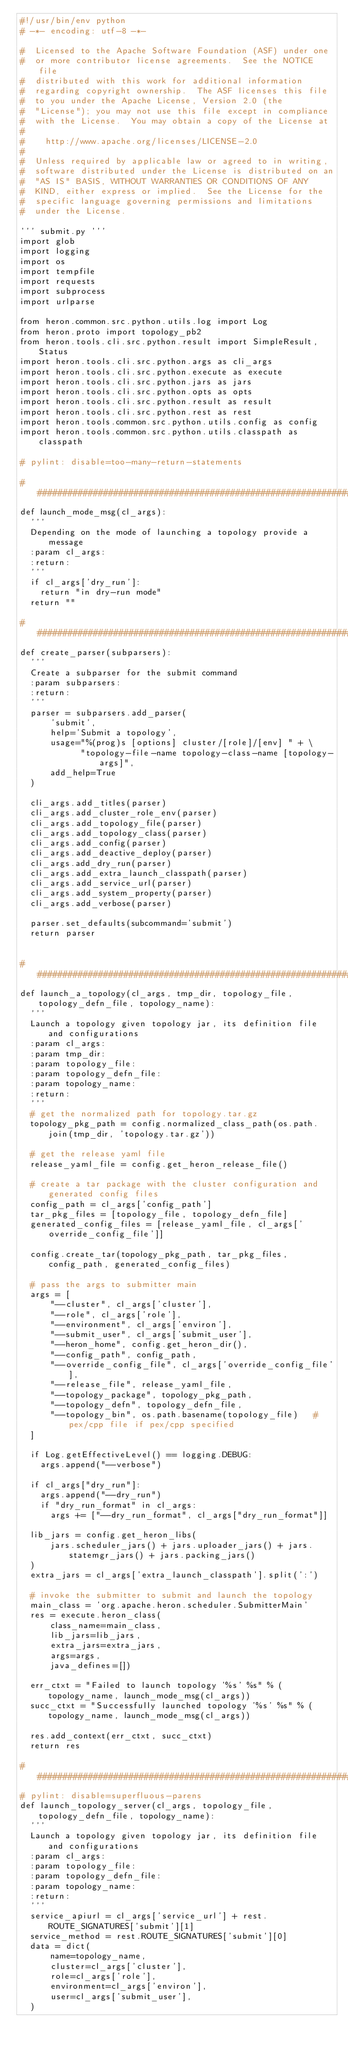<code> <loc_0><loc_0><loc_500><loc_500><_Python_>#!/usr/bin/env python
# -*- encoding: utf-8 -*-

#  Licensed to the Apache Software Foundation (ASF) under one
#  or more contributor license agreements.  See the NOTICE file
#  distributed with this work for additional information
#  regarding copyright ownership.  The ASF licenses this file
#  to you under the Apache License, Version 2.0 (the
#  "License"); you may not use this file except in compliance
#  with the License.  You may obtain a copy of the License at
#
#    http://www.apache.org/licenses/LICENSE-2.0
#
#  Unless required by applicable law or agreed to in writing,
#  software distributed under the License is distributed on an
#  "AS IS" BASIS, WITHOUT WARRANTIES OR CONDITIONS OF ANY
#  KIND, either express or implied.  See the License for the
#  specific language governing permissions and limitations
#  under the License.

''' submit.py '''
import glob
import logging
import os
import tempfile
import requests
import subprocess
import urlparse

from heron.common.src.python.utils.log import Log
from heron.proto import topology_pb2
from heron.tools.cli.src.python.result import SimpleResult, Status
import heron.tools.cli.src.python.args as cli_args
import heron.tools.cli.src.python.execute as execute
import heron.tools.cli.src.python.jars as jars
import heron.tools.cli.src.python.opts as opts
import heron.tools.cli.src.python.result as result
import heron.tools.cli.src.python.rest as rest
import heron.tools.common.src.python.utils.config as config
import heron.tools.common.src.python.utils.classpath as classpath

# pylint: disable=too-many-return-statements

################################################################################
def launch_mode_msg(cl_args):
  '''
  Depending on the mode of launching a topology provide a message
  :param cl_args:
  :return:
  '''
  if cl_args['dry_run']:
    return "in dry-run mode"
  return ""

################################################################################
def create_parser(subparsers):
  '''
  Create a subparser for the submit command
  :param subparsers:
  :return:
  '''
  parser = subparsers.add_parser(
      'submit',
      help='Submit a topology',
      usage="%(prog)s [options] cluster/[role]/[env] " + \
            "topology-file-name topology-class-name [topology-args]",
      add_help=True
  )

  cli_args.add_titles(parser)
  cli_args.add_cluster_role_env(parser)
  cli_args.add_topology_file(parser)
  cli_args.add_topology_class(parser)
  cli_args.add_config(parser)
  cli_args.add_deactive_deploy(parser)
  cli_args.add_dry_run(parser)
  cli_args.add_extra_launch_classpath(parser)
  cli_args.add_service_url(parser)
  cli_args.add_system_property(parser)
  cli_args.add_verbose(parser)

  parser.set_defaults(subcommand='submit')
  return parser


################################################################################
def launch_a_topology(cl_args, tmp_dir, topology_file, topology_defn_file, topology_name):
  '''
  Launch a topology given topology jar, its definition file and configurations
  :param cl_args:
  :param tmp_dir:
  :param topology_file:
  :param topology_defn_file:
  :param topology_name:
  :return:
  '''
  # get the normalized path for topology.tar.gz
  topology_pkg_path = config.normalized_class_path(os.path.join(tmp_dir, 'topology.tar.gz'))

  # get the release yaml file
  release_yaml_file = config.get_heron_release_file()

  # create a tar package with the cluster configuration and generated config files
  config_path = cl_args['config_path']
  tar_pkg_files = [topology_file, topology_defn_file]
  generated_config_files = [release_yaml_file, cl_args['override_config_file']]

  config.create_tar(topology_pkg_path, tar_pkg_files, config_path, generated_config_files)

  # pass the args to submitter main
  args = [
      "--cluster", cl_args['cluster'],
      "--role", cl_args['role'],
      "--environment", cl_args['environ'],
      "--submit_user", cl_args['submit_user'],
      "--heron_home", config.get_heron_dir(),
      "--config_path", config_path,
      "--override_config_file", cl_args['override_config_file'],
      "--release_file", release_yaml_file,
      "--topology_package", topology_pkg_path,
      "--topology_defn", topology_defn_file,
      "--topology_bin", os.path.basename(topology_file)   # pex/cpp file if pex/cpp specified
  ]

  if Log.getEffectiveLevel() == logging.DEBUG:
    args.append("--verbose")

  if cl_args["dry_run"]:
    args.append("--dry_run")
    if "dry_run_format" in cl_args:
      args += ["--dry_run_format", cl_args["dry_run_format"]]

  lib_jars = config.get_heron_libs(
      jars.scheduler_jars() + jars.uploader_jars() + jars.statemgr_jars() + jars.packing_jars()
  )
  extra_jars = cl_args['extra_launch_classpath'].split(':')

  # invoke the submitter to submit and launch the topology
  main_class = 'org.apache.heron.scheduler.SubmitterMain'
  res = execute.heron_class(
      class_name=main_class,
      lib_jars=lib_jars,
      extra_jars=extra_jars,
      args=args,
      java_defines=[])

  err_ctxt = "Failed to launch topology '%s' %s" % (topology_name, launch_mode_msg(cl_args))
  succ_ctxt = "Successfully launched topology '%s' %s" % (topology_name, launch_mode_msg(cl_args))

  res.add_context(err_ctxt, succ_ctxt)
  return res

################################################################################
# pylint: disable=superfluous-parens
def launch_topology_server(cl_args, topology_file, topology_defn_file, topology_name):
  '''
  Launch a topology given topology jar, its definition file and configurations
  :param cl_args:
  :param topology_file:
  :param topology_defn_file:
  :param topology_name:
  :return:
  '''
  service_apiurl = cl_args['service_url'] + rest.ROUTE_SIGNATURES['submit'][1]
  service_method = rest.ROUTE_SIGNATURES['submit'][0]
  data = dict(
      name=topology_name,
      cluster=cl_args['cluster'],
      role=cl_args['role'],
      environment=cl_args['environ'],
      user=cl_args['submit_user'],
  )
</code> 